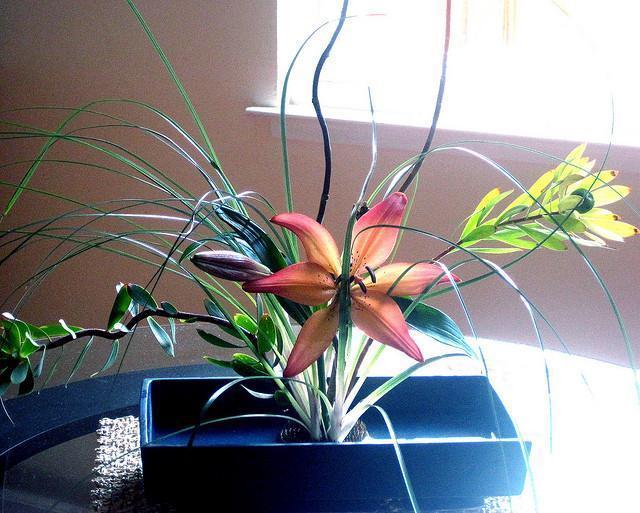How many flowers are in this scene?
Give a very brief answer. 1. 